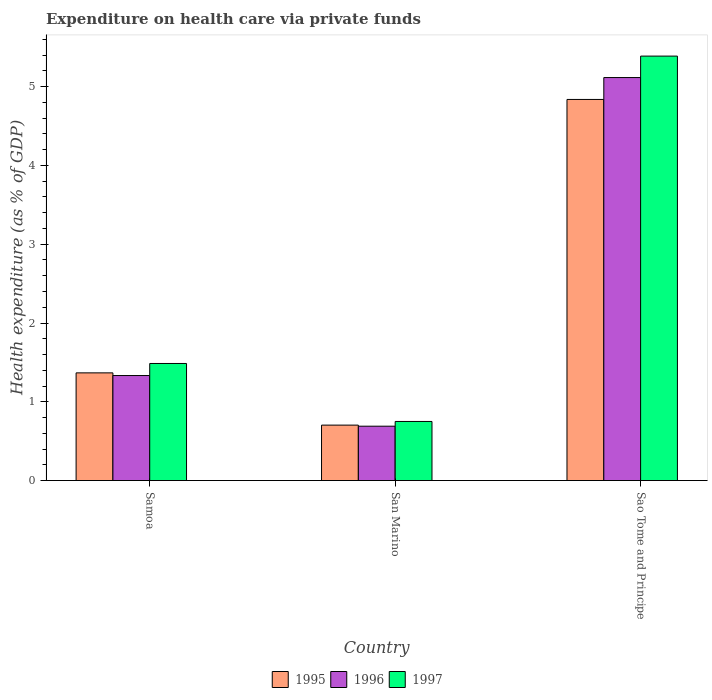Are the number of bars per tick equal to the number of legend labels?
Provide a succinct answer. Yes. How many bars are there on the 2nd tick from the right?
Give a very brief answer. 3. What is the label of the 2nd group of bars from the left?
Ensure brevity in your answer.  San Marino. In how many cases, is the number of bars for a given country not equal to the number of legend labels?
Provide a succinct answer. 0. What is the expenditure made on health care in 1997 in San Marino?
Provide a succinct answer. 0.75. Across all countries, what is the maximum expenditure made on health care in 1997?
Your response must be concise. 5.39. Across all countries, what is the minimum expenditure made on health care in 1996?
Your answer should be very brief. 0.69. In which country was the expenditure made on health care in 1996 maximum?
Your answer should be compact. Sao Tome and Principe. In which country was the expenditure made on health care in 1995 minimum?
Give a very brief answer. San Marino. What is the total expenditure made on health care in 1996 in the graph?
Keep it short and to the point. 7.14. What is the difference between the expenditure made on health care in 1995 in Samoa and that in San Marino?
Provide a succinct answer. 0.66. What is the difference between the expenditure made on health care in 1997 in Sao Tome and Principe and the expenditure made on health care in 1995 in Samoa?
Make the answer very short. 4.02. What is the average expenditure made on health care in 1995 per country?
Your answer should be very brief. 2.3. What is the difference between the expenditure made on health care of/in 1995 and expenditure made on health care of/in 1997 in San Marino?
Ensure brevity in your answer.  -0.05. In how many countries, is the expenditure made on health care in 1996 greater than 4.4 %?
Provide a short and direct response. 1. What is the ratio of the expenditure made on health care in 1997 in San Marino to that in Sao Tome and Principe?
Offer a very short reply. 0.14. Is the difference between the expenditure made on health care in 1995 in San Marino and Sao Tome and Principe greater than the difference between the expenditure made on health care in 1997 in San Marino and Sao Tome and Principe?
Offer a terse response. Yes. What is the difference between the highest and the second highest expenditure made on health care in 1997?
Keep it short and to the point. -0.74. What is the difference between the highest and the lowest expenditure made on health care in 1996?
Provide a succinct answer. 4.43. In how many countries, is the expenditure made on health care in 1995 greater than the average expenditure made on health care in 1995 taken over all countries?
Provide a succinct answer. 1. Is the sum of the expenditure made on health care in 1996 in Samoa and San Marino greater than the maximum expenditure made on health care in 1995 across all countries?
Provide a succinct answer. No. What does the 2nd bar from the right in Sao Tome and Principe represents?
Your response must be concise. 1996. Is it the case that in every country, the sum of the expenditure made on health care in 1997 and expenditure made on health care in 1996 is greater than the expenditure made on health care in 1995?
Give a very brief answer. Yes. How many bars are there?
Provide a succinct answer. 9. Does the graph contain grids?
Give a very brief answer. No. Where does the legend appear in the graph?
Your answer should be very brief. Bottom center. How many legend labels are there?
Make the answer very short. 3. How are the legend labels stacked?
Provide a short and direct response. Horizontal. What is the title of the graph?
Your response must be concise. Expenditure on health care via private funds. What is the label or title of the X-axis?
Your answer should be compact. Country. What is the label or title of the Y-axis?
Make the answer very short. Health expenditure (as % of GDP). What is the Health expenditure (as % of GDP) of 1995 in Samoa?
Offer a terse response. 1.37. What is the Health expenditure (as % of GDP) of 1996 in Samoa?
Your answer should be very brief. 1.33. What is the Health expenditure (as % of GDP) of 1997 in Samoa?
Your answer should be very brief. 1.49. What is the Health expenditure (as % of GDP) in 1995 in San Marino?
Keep it short and to the point. 0.7. What is the Health expenditure (as % of GDP) in 1996 in San Marino?
Your answer should be compact. 0.69. What is the Health expenditure (as % of GDP) of 1997 in San Marino?
Provide a succinct answer. 0.75. What is the Health expenditure (as % of GDP) in 1995 in Sao Tome and Principe?
Your answer should be very brief. 4.84. What is the Health expenditure (as % of GDP) in 1996 in Sao Tome and Principe?
Your response must be concise. 5.12. What is the Health expenditure (as % of GDP) in 1997 in Sao Tome and Principe?
Give a very brief answer. 5.39. Across all countries, what is the maximum Health expenditure (as % of GDP) in 1995?
Provide a short and direct response. 4.84. Across all countries, what is the maximum Health expenditure (as % of GDP) of 1996?
Give a very brief answer. 5.12. Across all countries, what is the maximum Health expenditure (as % of GDP) in 1997?
Your response must be concise. 5.39. Across all countries, what is the minimum Health expenditure (as % of GDP) of 1995?
Your response must be concise. 0.7. Across all countries, what is the minimum Health expenditure (as % of GDP) in 1996?
Your response must be concise. 0.69. Across all countries, what is the minimum Health expenditure (as % of GDP) in 1997?
Your answer should be very brief. 0.75. What is the total Health expenditure (as % of GDP) of 1995 in the graph?
Ensure brevity in your answer.  6.91. What is the total Health expenditure (as % of GDP) of 1996 in the graph?
Provide a short and direct response. 7.14. What is the total Health expenditure (as % of GDP) of 1997 in the graph?
Keep it short and to the point. 7.62. What is the difference between the Health expenditure (as % of GDP) in 1995 in Samoa and that in San Marino?
Provide a succinct answer. 0.66. What is the difference between the Health expenditure (as % of GDP) in 1996 in Samoa and that in San Marino?
Provide a short and direct response. 0.64. What is the difference between the Health expenditure (as % of GDP) in 1997 in Samoa and that in San Marino?
Provide a succinct answer. 0.74. What is the difference between the Health expenditure (as % of GDP) in 1995 in Samoa and that in Sao Tome and Principe?
Offer a terse response. -3.47. What is the difference between the Health expenditure (as % of GDP) of 1996 in Samoa and that in Sao Tome and Principe?
Make the answer very short. -3.78. What is the difference between the Health expenditure (as % of GDP) in 1997 in Samoa and that in Sao Tome and Principe?
Your answer should be very brief. -3.9. What is the difference between the Health expenditure (as % of GDP) in 1995 in San Marino and that in Sao Tome and Principe?
Your response must be concise. -4.13. What is the difference between the Health expenditure (as % of GDP) in 1996 in San Marino and that in Sao Tome and Principe?
Ensure brevity in your answer.  -4.43. What is the difference between the Health expenditure (as % of GDP) in 1997 in San Marino and that in Sao Tome and Principe?
Keep it short and to the point. -4.64. What is the difference between the Health expenditure (as % of GDP) in 1995 in Samoa and the Health expenditure (as % of GDP) in 1996 in San Marino?
Provide a succinct answer. 0.68. What is the difference between the Health expenditure (as % of GDP) in 1995 in Samoa and the Health expenditure (as % of GDP) in 1997 in San Marino?
Offer a terse response. 0.62. What is the difference between the Health expenditure (as % of GDP) of 1996 in Samoa and the Health expenditure (as % of GDP) of 1997 in San Marino?
Offer a terse response. 0.58. What is the difference between the Health expenditure (as % of GDP) of 1995 in Samoa and the Health expenditure (as % of GDP) of 1996 in Sao Tome and Principe?
Your answer should be very brief. -3.75. What is the difference between the Health expenditure (as % of GDP) of 1995 in Samoa and the Health expenditure (as % of GDP) of 1997 in Sao Tome and Principe?
Ensure brevity in your answer.  -4.02. What is the difference between the Health expenditure (as % of GDP) of 1996 in Samoa and the Health expenditure (as % of GDP) of 1997 in Sao Tome and Principe?
Offer a terse response. -4.05. What is the difference between the Health expenditure (as % of GDP) in 1995 in San Marino and the Health expenditure (as % of GDP) in 1996 in Sao Tome and Principe?
Ensure brevity in your answer.  -4.41. What is the difference between the Health expenditure (as % of GDP) of 1995 in San Marino and the Health expenditure (as % of GDP) of 1997 in Sao Tome and Principe?
Make the answer very short. -4.68. What is the difference between the Health expenditure (as % of GDP) of 1996 in San Marino and the Health expenditure (as % of GDP) of 1997 in Sao Tome and Principe?
Your answer should be very brief. -4.7. What is the average Health expenditure (as % of GDP) in 1995 per country?
Make the answer very short. 2.3. What is the average Health expenditure (as % of GDP) of 1996 per country?
Your answer should be compact. 2.38. What is the average Health expenditure (as % of GDP) of 1997 per country?
Give a very brief answer. 2.54. What is the difference between the Health expenditure (as % of GDP) in 1995 and Health expenditure (as % of GDP) in 1996 in Samoa?
Give a very brief answer. 0.03. What is the difference between the Health expenditure (as % of GDP) in 1995 and Health expenditure (as % of GDP) in 1997 in Samoa?
Your answer should be very brief. -0.12. What is the difference between the Health expenditure (as % of GDP) in 1996 and Health expenditure (as % of GDP) in 1997 in Samoa?
Offer a terse response. -0.15. What is the difference between the Health expenditure (as % of GDP) of 1995 and Health expenditure (as % of GDP) of 1996 in San Marino?
Provide a short and direct response. 0.01. What is the difference between the Health expenditure (as % of GDP) in 1995 and Health expenditure (as % of GDP) in 1997 in San Marino?
Provide a short and direct response. -0.05. What is the difference between the Health expenditure (as % of GDP) of 1996 and Health expenditure (as % of GDP) of 1997 in San Marino?
Your answer should be very brief. -0.06. What is the difference between the Health expenditure (as % of GDP) of 1995 and Health expenditure (as % of GDP) of 1996 in Sao Tome and Principe?
Your answer should be very brief. -0.28. What is the difference between the Health expenditure (as % of GDP) of 1995 and Health expenditure (as % of GDP) of 1997 in Sao Tome and Principe?
Your response must be concise. -0.55. What is the difference between the Health expenditure (as % of GDP) of 1996 and Health expenditure (as % of GDP) of 1997 in Sao Tome and Principe?
Provide a short and direct response. -0.27. What is the ratio of the Health expenditure (as % of GDP) in 1995 in Samoa to that in San Marino?
Keep it short and to the point. 1.94. What is the ratio of the Health expenditure (as % of GDP) of 1996 in Samoa to that in San Marino?
Provide a succinct answer. 1.93. What is the ratio of the Health expenditure (as % of GDP) in 1997 in Samoa to that in San Marino?
Offer a very short reply. 1.98. What is the ratio of the Health expenditure (as % of GDP) of 1995 in Samoa to that in Sao Tome and Principe?
Give a very brief answer. 0.28. What is the ratio of the Health expenditure (as % of GDP) of 1996 in Samoa to that in Sao Tome and Principe?
Your response must be concise. 0.26. What is the ratio of the Health expenditure (as % of GDP) of 1997 in Samoa to that in Sao Tome and Principe?
Offer a very short reply. 0.28. What is the ratio of the Health expenditure (as % of GDP) in 1995 in San Marino to that in Sao Tome and Principe?
Your answer should be compact. 0.15. What is the ratio of the Health expenditure (as % of GDP) in 1996 in San Marino to that in Sao Tome and Principe?
Your answer should be very brief. 0.13. What is the ratio of the Health expenditure (as % of GDP) of 1997 in San Marino to that in Sao Tome and Principe?
Provide a short and direct response. 0.14. What is the difference between the highest and the second highest Health expenditure (as % of GDP) of 1995?
Keep it short and to the point. 3.47. What is the difference between the highest and the second highest Health expenditure (as % of GDP) of 1996?
Your answer should be compact. 3.78. What is the difference between the highest and the second highest Health expenditure (as % of GDP) in 1997?
Ensure brevity in your answer.  3.9. What is the difference between the highest and the lowest Health expenditure (as % of GDP) of 1995?
Give a very brief answer. 4.13. What is the difference between the highest and the lowest Health expenditure (as % of GDP) of 1996?
Offer a very short reply. 4.43. What is the difference between the highest and the lowest Health expenditure (as % of GDP) of 1997?
Keep it short and to the point. 4.64. 